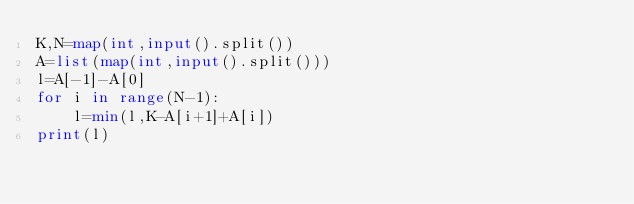Convert code to text. <code><loc_0><loc_0><loc_500><loc_500><_Python_>K,N=map(int,input().split())
A=list(map(int,input().split()))
l=A[-1]-A[0]
for i in range(N-1):
    l=min(l,K-A[i+1]+A[i])
print(l)</code> 